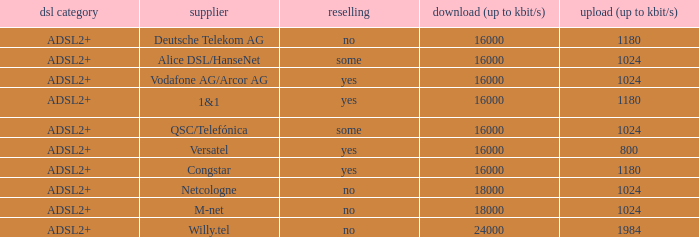How many providers are there where the resale category is yes and bandwith is up is 1024? 1.0. 